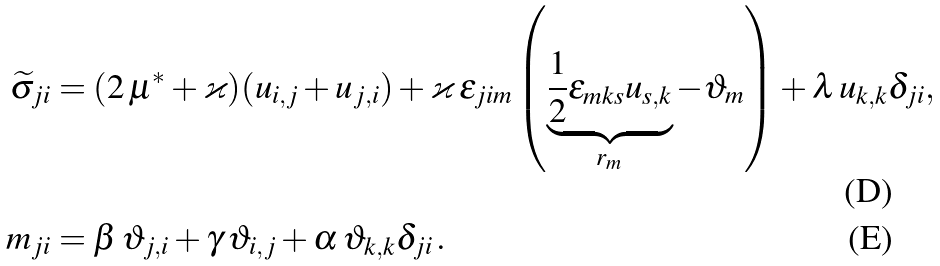<formula> <loc_0><loc_0><loc_500><loc_500>\widetilde { \sigma } _ { j i } & = ( 2 \, \mu ^ { * } + \varkappa ) ( u _ { i , j } + u _ { j , i } ) + \varkappa \, \epsilon _ { j i m } \left ( \underbrace { \frac { 1 } { 2 } \epsilon _ { m k s } u _ { s , k } } _ { r _ { m } } - \vartheta _ { m } \right ) + \lambda \, u _ { k , k } \delta _ { j i } , \\ m _ { j i } & = \beta \, \vartheta _ { j , i } + \gamma \, \vartheta _ { i , j } + \alpha \, \vartheta _ { k , k } \delta _ { j i } \, .</formula> 